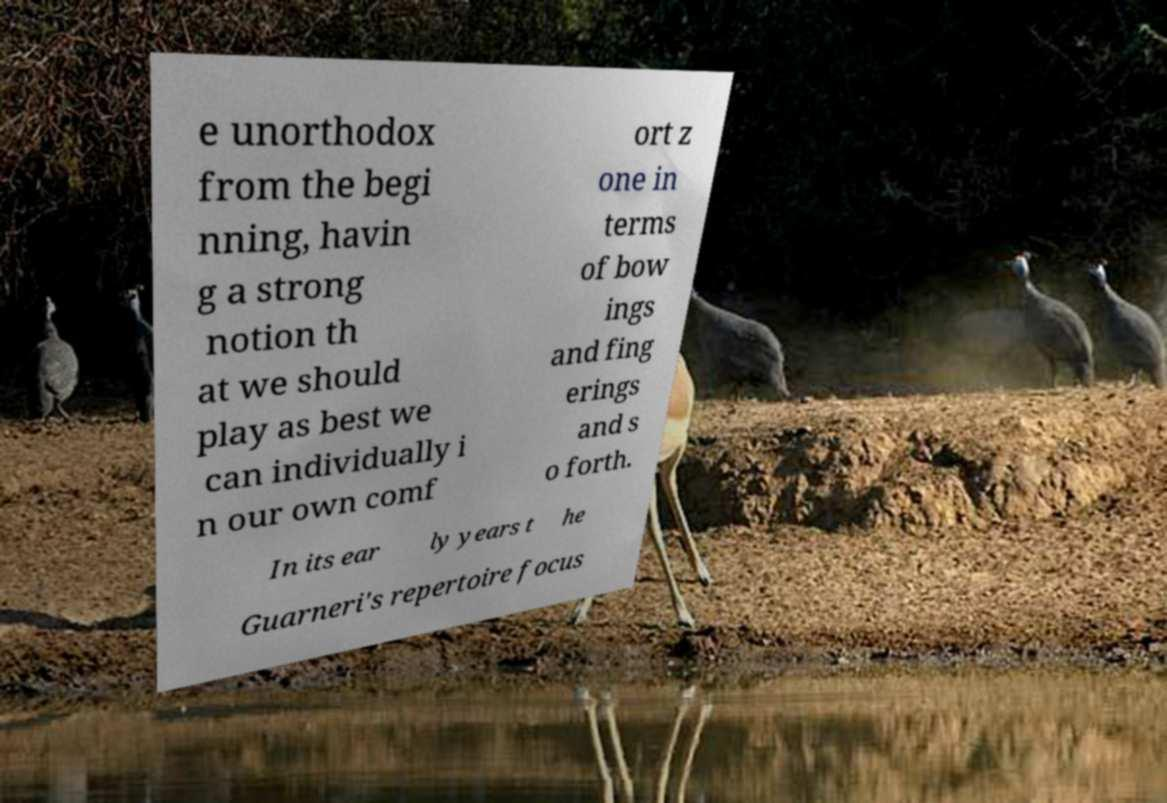I need the written content from this picture converted into text. Can you do that? e unorthodox from the begi nning, havin g a strong notion th at we should play as best we can individually i n our own comf ort z one in terms of bow ings and fing erings and s o forth. In its ear ly years t he Guarneri's repertoire focus 